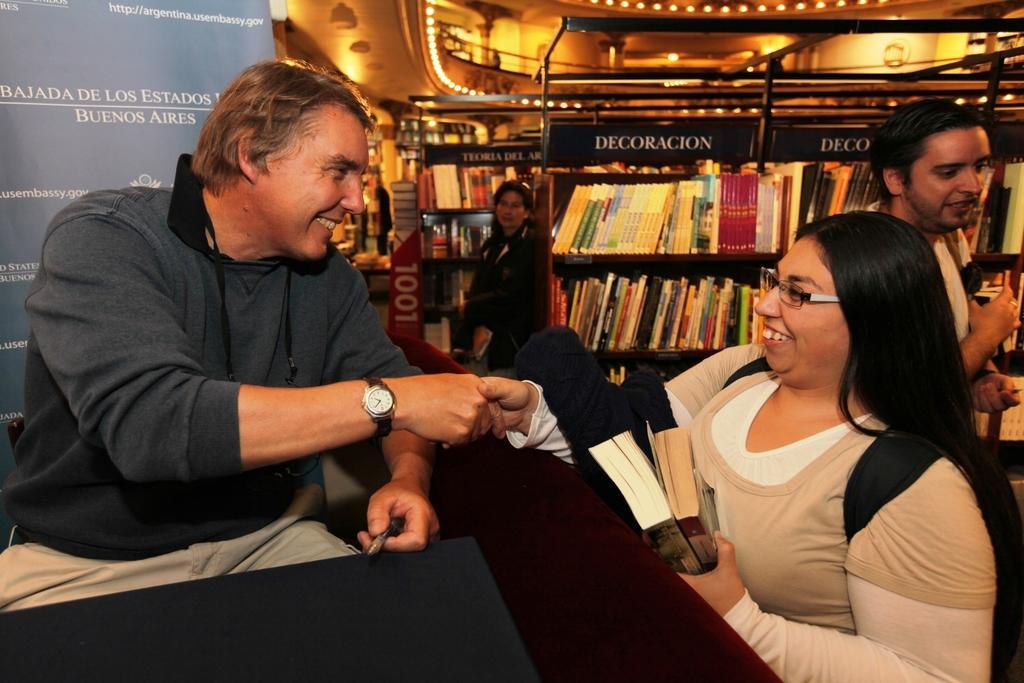In one or two sentences, can you explain what this image depicts? In this picture we can see a group of people and in the background we can see bookshelves, boards and some objects. 